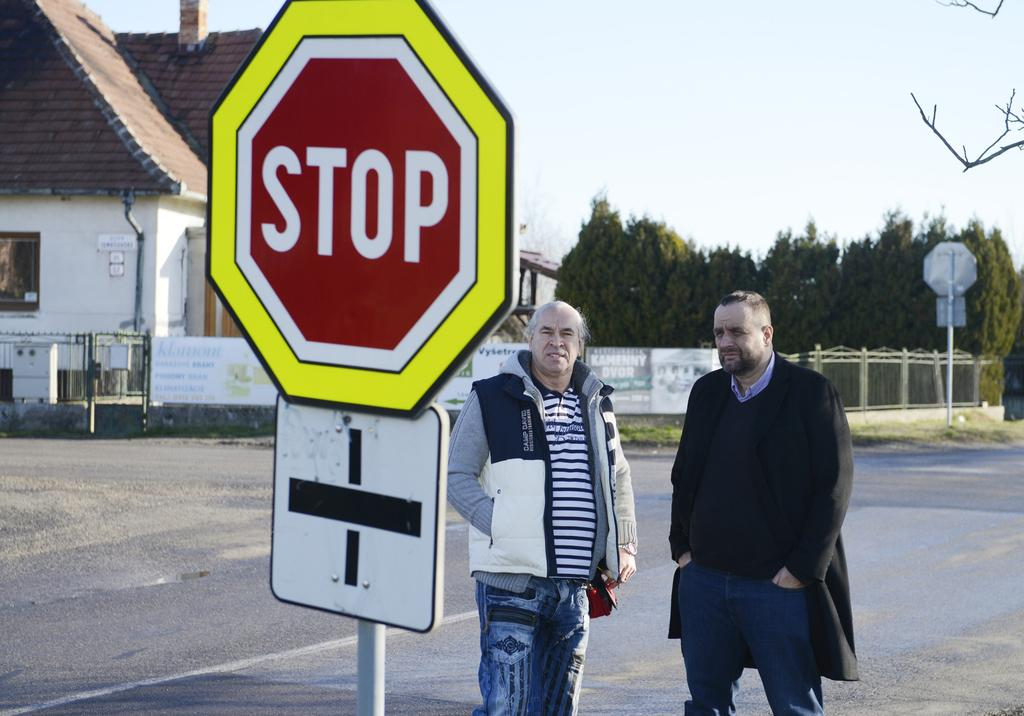Provide a one-sentence caption for the provided image. Two men standing beside a stop sign in the road. 